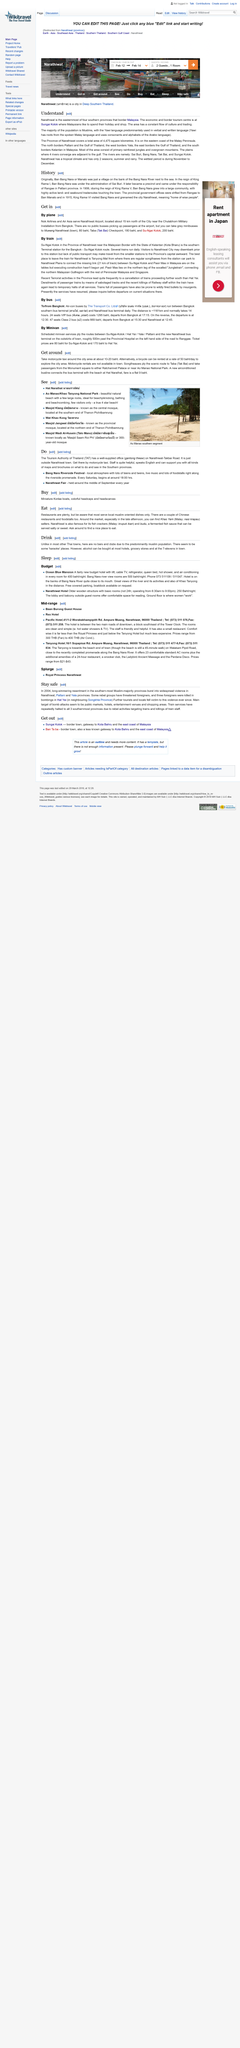Draw attention to some important aspects in this diagram. There are "karaoke" places in the area. The province of Narathiwat is located on the eastern coast of the Malay Peninsula. Air-conditioned buses operate between the terminals in Bangkok. The Ocean Blue Mansion is located on the banks of the Bang Nara River, providing guests with stunning views of the river and its surroundings. The Narathiwat Fair is held in the middle of September every year. 